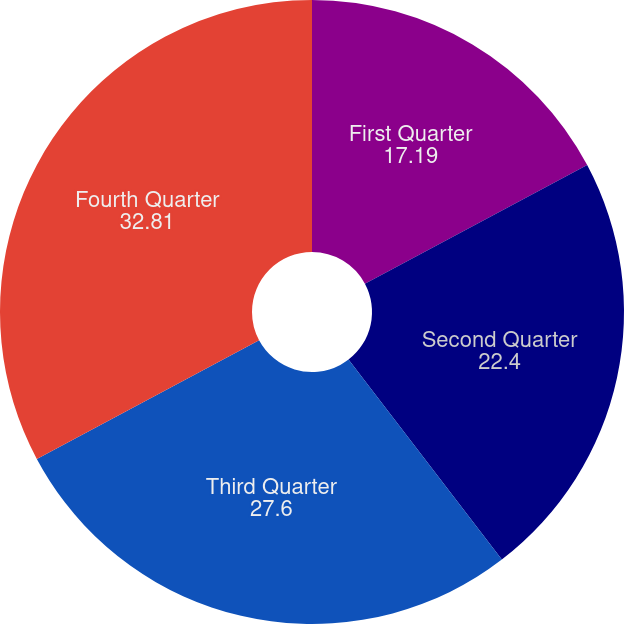Convert chart. <chart><loc_0><loc_0><loc_500><loc_500><pie_chart><fcel>First Quarter<fcel>Second Quarter<fcel>Third Quarter<fcel>Fourth Quarter<nl><fcel>17.19%<fcel>22.4%<fcel>27.6%<fcel>32.81%<nl></chart> 